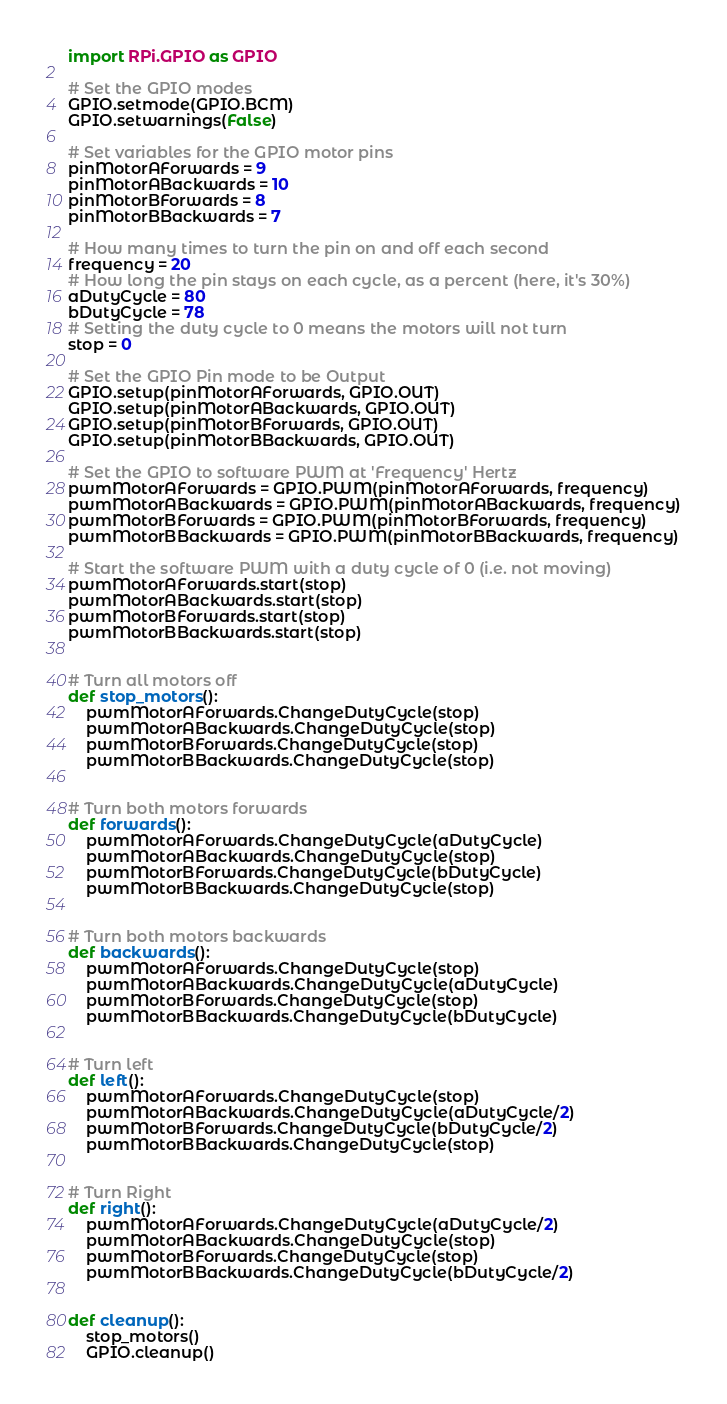<code> <loc_0><loc_0><loc_500><loc_500><_Python_>import RPi.GPIO as GPIO

# Set the GPIO modes
GPIO.setmode(GPIO.BCM)
GPIO.setwarnings(False)

# Set variables for the GPIO motor pins
pinMotorAForwards = 9
pinMotorABackwards = 10
pinMotorBForwards = 8
pinMotorBBackwards = 7

# How many times to turn the pin on and off each second
frequency = 20
# How long the pin stays on each cycle, as a percent (here, it's 30%)
aDutyCycle = 80
bDutyCycle = 78
# Setting the duty cycle to 0 means the motors will not turn
stop = 0

# Set the GPIO Pin mode to be Output
GPIO.setup(pinMotorAForwards, GPIO.OUT)
GPIO.setup(pinMotorABackwards, GPIO.OUT)
GPIO.setup(pinMotorBForwards, GPIO.OUT)
GPIO.setup(pinMotorBBackwards, GPIO.OUT)

# Set the GPIO to software PWM at 'Frequency' Hertz
pwmMotorAForwards = GPIO.PWM(pinMotorAForwards, frequency)
pwmMotorABackwards = GPIO.PWM(pinMotorABackwards, frequency)
pwmMotorBForwards = GPIO.PWM(pinMotorBForwards, frequency)
pwmMotorBBackwards = GPIO.PWM(pinMotorBBackwards, frequency)

# Start the software PWM with a duty cycle of 0 (i.e. not moving)
pwmMotorAForwards.start(stop)
pwmMotorABackwards.start(stop)
pwmMotorBForwards.start(stop)
pwmMotorBBackwards.start(stop)


# Turn all motors off
def stop_motors():
    pwmMotorAForwards.ChangeDutyCycle(stop)
    pwmMotorABackwards.ChangeDutyCycle(stop)
    pwmMotorBForwards.ChangeDutyCycle(stop)
    pwmMotorBBackwards.ChangeDutyCycle(stop)


# Turn both motors forwards
def forwards():
    pwmMotorAForwards.ChangeDutyCycle(aDutyCycle)
    pwmMotorABackwards.ChangeDutyCycle(stop)
    pwmMotorBForwards.ChangeDutyCycle(bDutyCycle)
    pwmMotorBBackwards.ChangeDutyCycle(stop)


# Turn both motors backwards
def backwards():
    pwmMotorAForwards.ChangeDutyCycle(stop)
    pwmMotorABackwards.ChangeDutyCycle(aDutyCycle)
    pwmMotorBForwards.ChangeDutyCycle(stop)
    pwmMotorBBackwards.ChangeDutyCycle(bDutyCycle)


# Turn left
def left():
    pwmMotorAForwards.ChangeDutyCycle(stop)
    pwmMotorABackwards.ChangeDutyCycle(aDutyCycle/2)
    pwmMotorBForwards.ChangeDutyCycle(bDutyCycle/2)
    pwmMotorBBackwards.ChangeDutyCycle(stop)


# Turn Right
def right():
    pwmMotorAForwards.ChangeDutyCycle(aDutyCycle/2)
    pwmMotorABackwards.ChangeDutyCycle(stop)
    pwmMotorBForwards.ChangeDutyCycle(stop)
    pwmMotorBBackwards.ChangeDutyCycle(bDutyCycle/2)


def cleanup():
    stop_motors()
    GPIO.cleanup()
</code> 